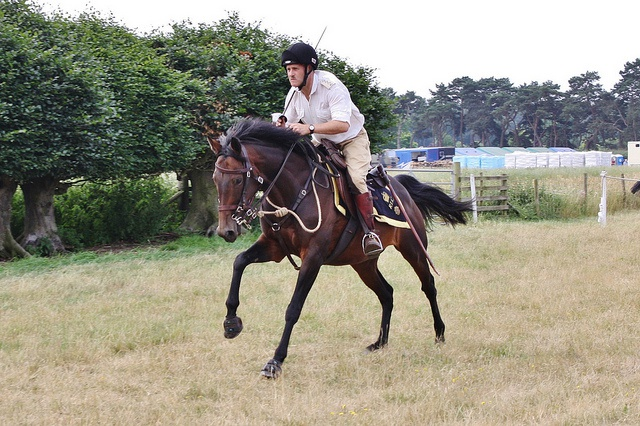Describe the objects in this image and their specific colors. I can see horse in gray, black, maroon, and darkgray tones, people in gray, lavender, black, darkgray, and pink tones, and people in gray, lavender, and darkgray tones in this image. 